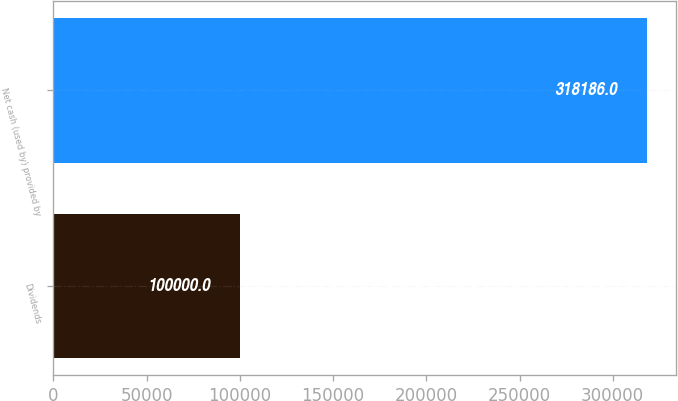Convert chart to OTSL. <chart><loc_0><loc_0><loc_500><loc_500><bar_chart><fcel>Dividends<fcel>Net cash (used by) provided by<nl><fcel>100000<fcel>318186<nl></chart> 